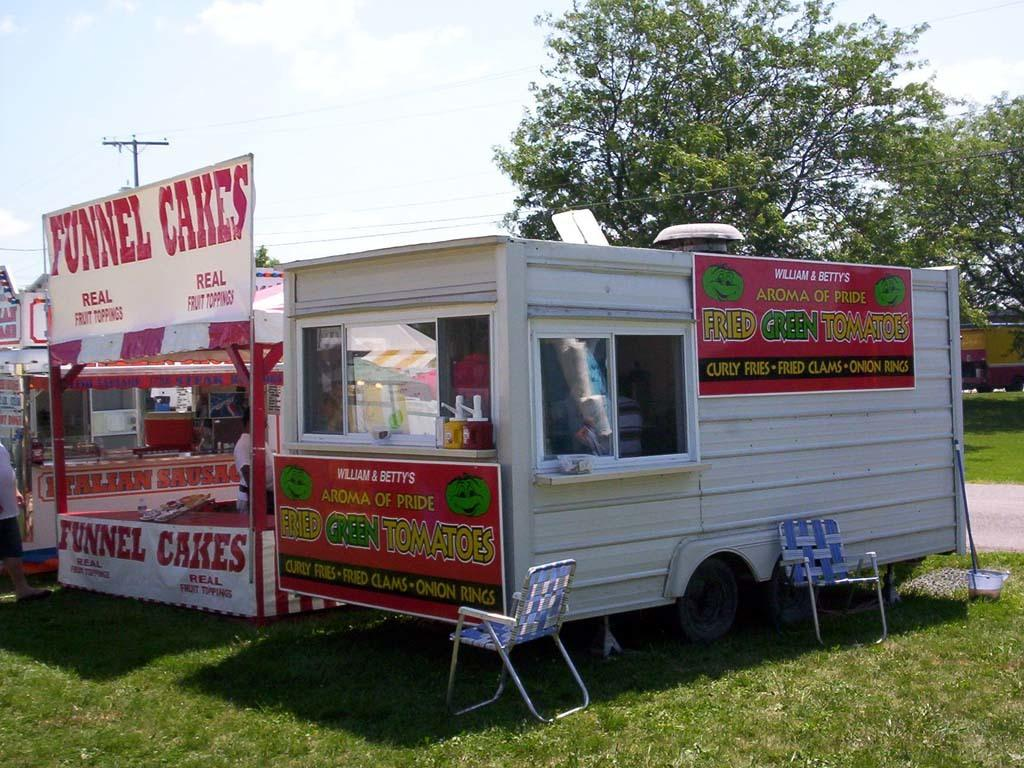What type of structures are in the image? There are stalls in the image. What type of furniture is in the image? There are chairs in the image. Where are the stalls and chairs located? The stalls and chairs are on green grass. What type of vegetation is in the image? Trees are present in the image. What is the condition of the sky in the image? The sky is bright in the image. Can you see any boats in the image? There are no boats present in the image. What type of connection is being made between the stalls and chairs in the image? There is no connection being made between the stalls and chairs in the image; they are simply placed on the grass. 